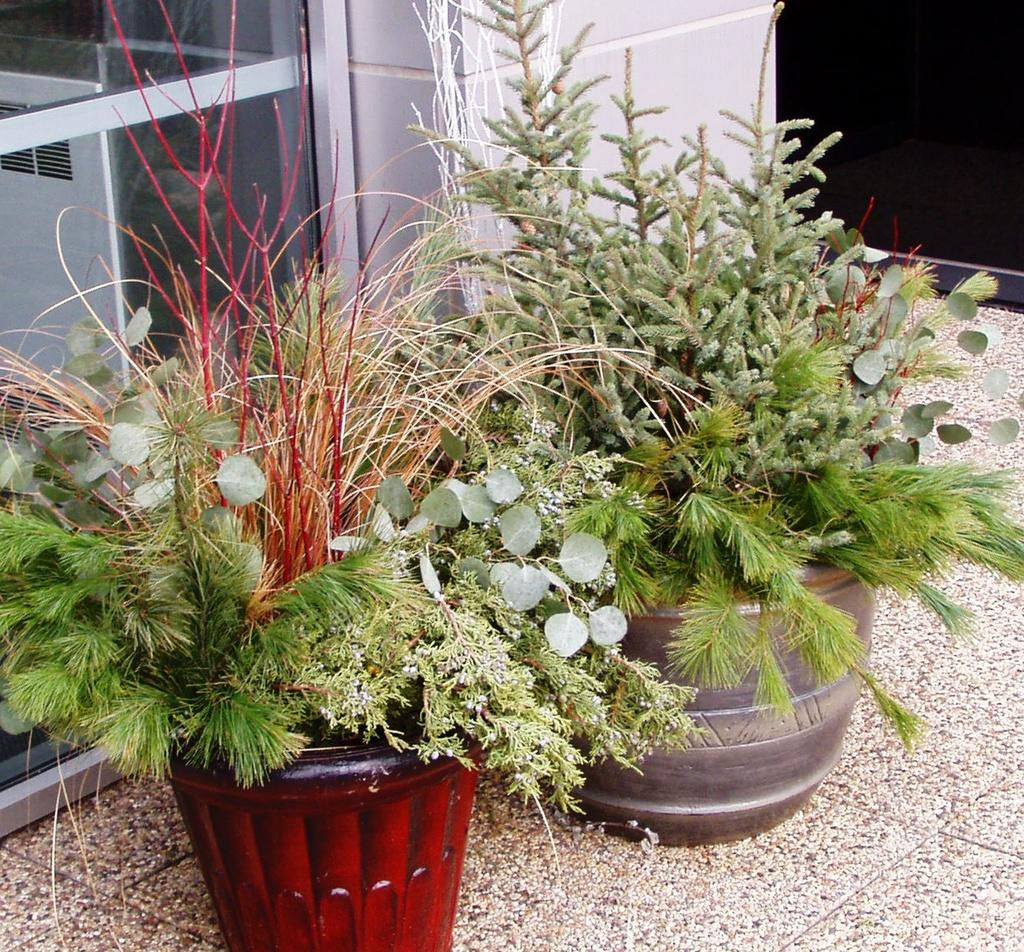What objects are on the floor in the image? There are planets on the floor in the image. What can be seen in the background of the image? There is glass and a wall visible in the background of the image. Where is the bed located in the image? There is no bed present in the image. What type of leaf can be seen falling from the ceiling in the image? There are no leaves present in the image. 